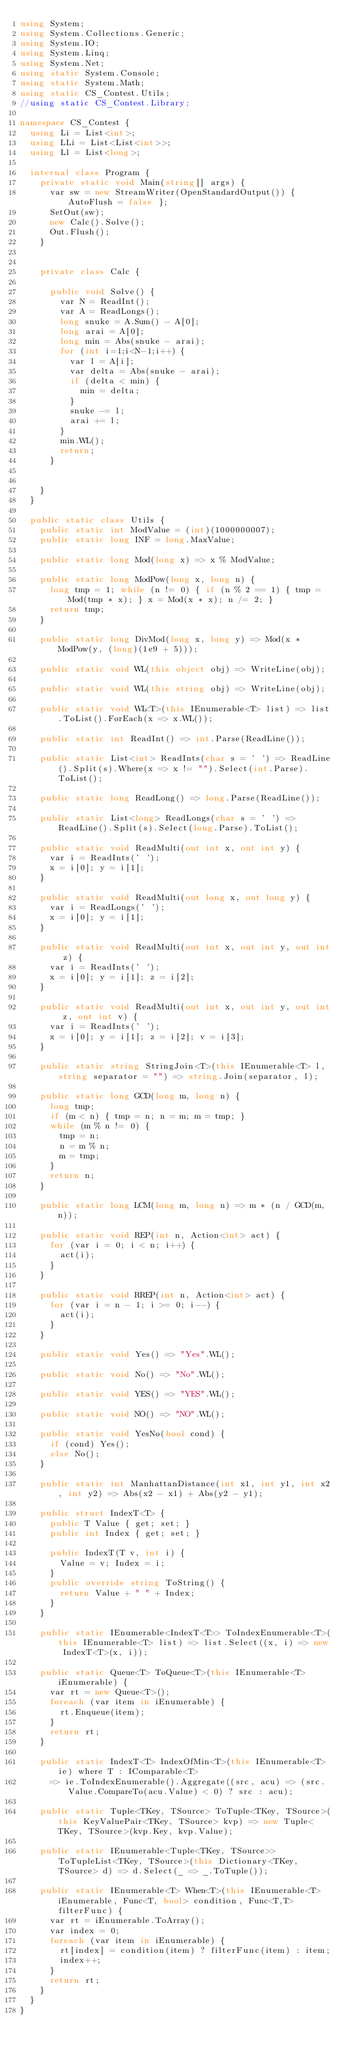<code> <loc_0><loc_0><loc_500><loc_500><_C#_>using System;
using System.Collections.Generic;
using System.IO;
using System.Linq;
using System.Net;
using static System.Console;
using static System.Math;
using static CS_Contest.Utils;
//using static CS_Contest.Library;

namespace CS_Contest {
	using Li = List<int>;
	using LLi = List<List<int>>;
	using Ll = List<long>;

	internal class Program {
		private static void Main(string[] args) {
			var sw = new StreamWriter(OpenStandardOutput()) { AutoFlush = false };
			SetOut(sw);
			new Calc().Solve();
			Out.Flush();
		}
		

		private class Calc {

			public void Solve() {
				var N = ReadInt();
				var A = ReadLongs();
				long snuke = A.Sum() - A[0];
				long arai = A[0];
				long min = Abs(snuke - arai);
				for (int i=1;i<N-1;i++) {
					var l = A[i];
					var delta = Abs(snuke - arai);
					if (delta < min) {
						min = delta;
					}
					snuke -= l;
					arai += l;
				}
				min.WL();
				return;
			}

			
		}
	}

	public static class Utils {
		public static int ModValue = (int)(1000000007);
		public static long INF = long.MaxValue;

		public static long Mod(long x) => x % ModValue;

		public static long ModPow(long x, long n) {
			long tmp = 1; while (n != 0) { if (n % 2 == 1) { tmp = Mod(tmp * x); } x = Mod(x * x); n /= 2; }
			return tmp;
		}

		public static long DivMod(long x, long y) => Mod(x * ModPow(y, (long)(1e9 + 5)));

		public static void WL(this object obj) => WriteLine(obj);

		public static void WL(this string obj) => WriteLine(obj);

		public static void WL<T>(this IEnumerable<T> list) => list.ToList().ForEach(x => x.WL());

		public static int ReadInt() => int.Parse(ReadLine());

		public static List<int> ReadInts(char s = ' ') => ReadLine().Split(s).Where(x => x != "").Select(int.Parse).ToList();

		public static long ReadLong() => long.Parse(ReadLine());

		public static List<long> ReadLongs(char s = ' ') => ReadLine().Split(s).Select(long.Parse).ToList();

		public static void ReadMulti(out int x, out int y) {
			var i = ReadInts(' ');
			x = i[0]; y = i[1];
		}

		public static void ReadMulti(out long x, out long y) {
			var i = ReadLongs(' ');
			x = i[0]; y = i[1];
		}

		public static void ReadMulti(out int x, out int y, out int z) {
			var i = ReadInts(' ');
			x = i[0]; y = i[1]; z = i[2];
		}

		public static void ReadMulti(out int x, out int y, out int z, out int v) {
			var i = ReadInts(' ');
			x = i[0]; y = i[1]; z = i[2]; v = i[3];
		}

		public static string StringJoin<T>(this IEnumerable<T> l, string separator = "") => string.Join(separator, l);

		public static long GCD(long m, long n) {
			long tmp;
			if (m < n) { tmp = n; n = m; m = tmp; }
			while (m % n != 0) {
				tmp = n;
				n = m % n;
				m = tmp;
			}
			return n;
		}

		public static long LCM(long m, long n) => m * (n / GCD(m, n));

		public static void REP(int n, Action<int> act) {
			for (var i = 0; i < n; i++) {
				act(i);
			}
		}

		public static void RREP(int n, Action<int> act) {
			for (var i = n - 1; i >= 0; i--) {
				act(i);
			}
		}

		public static void Yes() => "Yes".WL();

		public static void No() => "No".WL();

		public static void YES() => "YES".WL();

		public static void NO() => "NO".WL();

		public static void YesNo(bool cond) {
			if (cond) Yes();
			else No();
		}

		public static int ManhattanDistance(int x1, int y1, int x2, int y2) => Abs(x2 - x1) + Abs(y2 - y1);

		public struct IndexT<T> {
			public T Value { get; set; }
			public int Index { get; set; }

			public IndexT(T v, int i) {
				Value = v; Index = i;
			}
			public override string ToString() {
				return Value + " " + Index;
			}
		}

		public static IEnumerable<IndexT<T>> ToIndexEnumerable<T>(this IEnumerable<T> list) => list.Select((x, i) => new IndexT<T>(x, i));

		public static Queue<T> ToQueue<T>(this IEnumerable<T> iEnumerable) {
			var rt = new Queue<T>();
			foreach (var item in iEnumerable) {
				rt.Enqueue(item);
			}
			return rt;
		}

		public static IndexT<T> IndexOfMin<T>(this IEnumerable<T> ie) where T : IComparable<T>
			=> ie.ToIndexEnumerable().Aggregate((src, acu) => (src.Value.CompareTo(acu.Value) < 0) ? src : acu);

		public static Tuple<TKey, TSource> ToTuple<TKey, TSource>(this KeyValuePair<TKey, TSource> kvp) => new Tuple<TKey, TSource>(kvp.Key, kvp.Value);

		public static IEnumerable<Tuple<TKey, TSource>> ToTupleList<TKey, TSource>(this Dictionary<TKey, TSource> d) => d.Select(_ => _.ToTuple());

		public static IEnumerable<T> When<T>(this IEnumerable<T> iEnumerable, Func<T, bool> condition, Func<T,T> filterFunc) {
			var rt = iEnumerable.ToArray();
			var index = 0;
			foreach (var item in iEnumerable) {
				rt[index] = condition(item) ? filterFunc(item) : item;
				index++;
			}
			return rt;
		}
	}
}</code> 